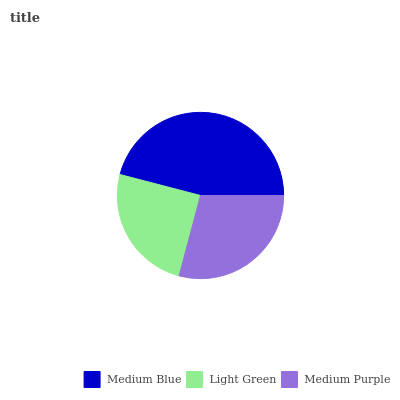Is Light Green the minimum?
Answer yes or no. Yes. Is Medium Blue the maximum?
Answer yes or no. Yes. Is Medium Purple the minimum?
Answer yes or no. No. Is Medium Purple the maximum?
Answer yes or no. No. Is Medium Purple greater than Light Green?
Answer yes or no. Yes. Is Light Green less than Medium Purple?
Answer yes or no. Yes. Is Light Green greater than Medium Purple?
Answer yes or no. No. Is Medium Purple less than Light Green?
Answer yes or no. No. Is Medium Purple the high median?
Answer yes or no. Yes. Is Medium Purple the low median?
Answer yes or no. Yes. Is Medium Blue the high median?
Answer yes or no. No. Is Medium Blue the low median?
Answer yes or no. No. 